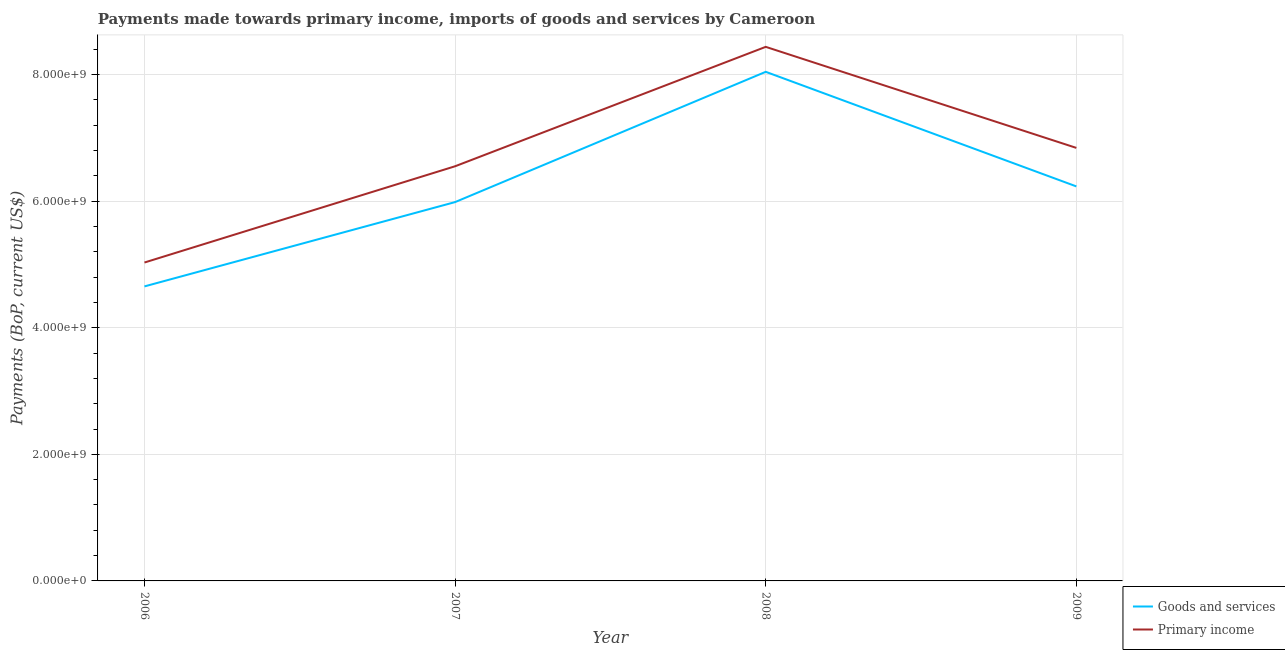Does the line corresponding to payments made towards primary income intersect with the line corresponding to payments made towards goods and services?
Provide a short and direct response. No. What is the payments made towards goods and services in 2006?
Provide a short and direct response. 4.65e+09. Across all years, what is the maximum payments made towards goods and services?
Give a very brief answer. 8.04e+09. Across all years, what is the minimum payments made towards primary income?
Give a very brief answer. 5.03e+09. In which year was the payments made towards primary income minimum?
Provide a short and direct response. 2006. What is the total payments made towards primary income in the graph?
Provide a succinct answer. 2.69e+1. What is the difference between the payments made towards primary income in 2006 and that in 2009?
Ensure brevity in your answer.  -1.81e+09. What is the difference between the payments made towards primary income in 2006 and the payments made towards goods and services in 2007?
Ensure brevity in your answer.  -9.55e+08. What is the average payments made towards goods and services per year?
Your response must be concise. 6.23e+09. In the year 2006, what is the difference between the payments made towards goods and services and payments made towards primary income?
Provide a short and direct response. -3.77e+08. In how many years, is the payments made towards primary income greater than 1200000000 US$?
Give a very brief answer. 4. What is the ratio of the payments made towards primary income in 2006 to that in 2009?
Ensure brevity in your answer.  0.74. Is the difference between the payments made towards primary income in 2007 and 2008 greater than the difference between the payments made towards goods and services in 2007 and 2008?
Your response must be concise. Yes. What is the difference between the highest and the second highest payments made towards primary income?
Your answer should be compact. 1.60e+09. What is the difference between the highest and the lowest payments made towards primary income?
Ensure brevity in your answer.  3.41e+09. Does the payments made towards goods and services monotonically increase over the years?
Your answer should be very brief. No. Does the graph contain any zero values?
Ensure brevity in your answer.  No. How many legend labels are there?
Give a very brief answer. 2. What is the title of the graph?
Make the answer very short. Payments made towards primary income, imports of goods and services by Cameroon. Does "Automatic Teller Machines" appear as one of the legend labels in the graph?
Your answer should be very brief. No. What is the label or title of the X-axis?
Give a very brief answer. Year. What is the label or title of the Y-axis?
Provide a succinct answer. Payments (BoP, current US$). What is the Payments (BoP, current US$) of Goods and services in 2006?
Your response must be concise. 4.65e+09. What is the Payments (BoP, current US$) of Primary income in 2006?
Offer a very short reply. 5.03e+09. What is the Payments (BoP, current US$) in Goods and services in 2007?
Keep it short and to the point. 5.99e+09. What is the Payments (BoP, current US$) in Primary income in 2007?
Provide a short and direct response. 6.55e+09. What is the Payments (BoP, current US$) of Goods and services in 2008?
Keep it short and to the point. 8.04e+09. What is the Payments (BoP, current US$) in Primary income in 2008?
Keep it short and to the point. 8.44e+09. What is the Payments (BoP, current US$) of Goods and services in 2009?
Give a very brief answer. 6.23e+09. What is the Payments (BoP, current US$) in Primary income in 2009?
Provide a succinct answer. 6.84e+09. Across all years, what is the maximum Payments (BoP, current US$) in Goods and services?
Keep it short and to the point. 8.04e+09. Across all years, what is the maximum Payments (BoP, current US$) in Primary income?
Give a very brief answer. 8.44e+09. Across all years, what is the minimum Payments (BoP, current US$) in Goods and services?
Provide a succinct answer. 4.65e+09. Across all years, what is the minimum Payments (BoP, current US$) in Primary income?
Your answer should be very brief. 5.03e+09. What is the total Payments (BoP, current US$) of Goods and services in the graph?
Offer a very short reply. 2.49e+1. What is the total Payments (BoP, current US$) of Primary income in the graph?
Your answer should be very brief. 2.69e+1. What is the difference between the Payments (BoP, current US$) in Goods and services in 2006 and that in 2007?
Your answer should be very brief. -1.33e+09. What is the difference between the Payments (BoP, current US$) in Primary income in 2006 and that in 2007?
Keep it short and to the point. -1.52e+09. What is the difference between the Payments (BoP, current US$) of Goods and services in 2006 and that in 2008?
Your response must be concise. -3.39e+09. What is the difference between the Payments (BoP, current US$) of Primary income in 2006 and that in 2008?
Give a very brief answer. -3.41e+09. What is the difference between the Payments (BoP, current US$) in Goods and services in 2006 and that in 2009?
Make the answer very short. -1.58e+09. What is the difference between the Payments (BoP, current US$) in Primary income in 2006 and that in 2009?
Provide a succinct answer. -1.81e+09. What is the difference between the Payments (BoP, current US$) of Goods and services in 2007 and that in 2008?
Your answer should be compact. -2.06e+09. What is the difference between the Payments (BoP, current US$) of Primary income in 2007 and that in 2008?
Make the answer very short. -1.89e+09. What is the difference between the Payments (BoP, current US$) of Goods and services in 2007 and that in 2009?
Give a very brief answer. -2.48e+08. What is the difference between the Payments (BoP, current US$) of Primary income in 2007 and that in 2009?
Provide a short and direct response. -2.90e+08. What is the difference between the Payments (BoP, current US$) of Goods and services in 2008 and that in 2009?
Your answer should be very brief. 1.81e+09. What is the difference between the Payments (BoP, current US$) of Primary income in 2008 and that in 2009?
Make the answer very short. 1.60e+09. What is the difference between the Payments (BoP, current US$) in Goods and services in 2006 and the Payments (BoP, current US$) in Primary income in 2007?
Your answer should be compact. -1.90e+09. What is the difference between the Payments (BoP, current US$) of Goods and services in 2006 and the Payments (BoP, current US$) of Primary income in 2008?
Keep it short and to the point. -3.78e+09. What is the difference between the Payments (BoP, current US$) of Goods and services in 2006 and the Payments (BoP, current US$) of Primary income in 2009?
Your response must be concise. -2.19e+09. What is the difference between the Payments (BoP, current US$) in Goods and services in 2007 and the Payments (BoP, current US$) in Primary income in 2008?
Your answer should be very brief. -2.45e+09. What is the difference between the Payments (BoP, current US$) in Goods and services in 2007 and the Payments (BoP, current US$) in Primary income in 2009?
Offer a terse response. -8.56e+08. What is the difference between the Payments (BoP, current US$) of Goods and services in 2008 and the Payments (BoP, current US$) of Primary income in 2009?
Give a very brief answer. 1.20e+09. What is the average Payments (BoP, current US$) of Goods and services per year?
Ensure brevity in your answer.  6.23e+09. What is the average Payments (BoP, current US$) in Primary income per year?
Offer a terse response. 6.72e+09. In the year 2006, what is the difference between the Payments (BoP, current US$) in Goods and services and Payments (BoP, current US$) in Primary income?
Give a very brief answer. -3.77e+08. In the year 2007, what is the difference between the Payments (BoP, current US$) in Goods and services and Payments (BoP, current US$) in Primary income?
Your answer should be compact. -5.66e+08. In the year 2008, what is the difference between the Payments (BoP, current US$) in Goods and services and Payments (BoP, current US$) in Primary income?
Provide a succinct answer. -3.95e+08. In the year 2009, what is the difference between the Payments (BoP, current US$) in Goods and services and Payments (BoP, current US$) in Primary income?
Ensure brevity in your answer.  -6.09e+08. What is the ratio of the Payments (BoP, current US$) in Goods and services in 2006 to that in 2007?
Offer a very short reply. 0.78. What is the ratio of the Payments (BoP, current US$) of Primary income in 2006 to that in 2007?
Provide a succinct answer. 0.77. What is the ratio of the Payments (BoP, current US$) of Goods and services in 2006 to that in 2008?
Offer a terse response. 0.58. What is the ratio of the Payments (BoP, current US$) of Primary income in 2006 to that in 2008?
Provide a succinct answer. 0.6. What is the ratio of the Payments (BoP, current US$) of Goods and services in 2006 to that in 2009?
Your answer should be very brief. 0.75. What is the ratio of the Payments (BoP, current US$) of Primary income in 2006 to that in 2009?
Your answer should be very brief. 0.74. What is the ratio of the Payments (BoP, current US$) of Goods and services in 2007 to that in 2008?
Your answer should be compact. 0.74. What is the ratio of the Payments (BoP, current US$) in Primary income in 2007 to that in 2008?
Offer a terse response. 0.78. What is the ratio of the Payments (BoP, current US$) in Goods and services in 2007 to that in 2009?
Provide a succinct answer. 0.96. What is the ratio of the Payments (BoP, current US$) of Primary income in 2007 to that in 2009?
Offer a terse response. 0.96. What is the ratio of the Payments (BoP, current US$) of Goods and services in 2008 to that in 2009?
Make the answer very short. 1.29. What is the ratio of the Payments (BoP, current US$) of Primary income in 2008 to that in 2009?
Provide a short and direct response. 1.23. What is the difference between the highest and the second highest Payments (BoP, current US$) of Goods and services?
Ensure brevity in your answer.  1.81e+09. What is the difference between the highest and the second highest Payments (BoP, current US$) of Primary income?
Give a very brief answer. 1.60e+09. What is the difference between the highest and the lowest Payments (BoP, current US$) of Goods and services?
Provide a short and direct response. 3.39e+09. What is the difference between the highest and the lowest Payments (BoP, current US$) in Primary income?
Ensure brevity in your answer.  3.41e+09. 